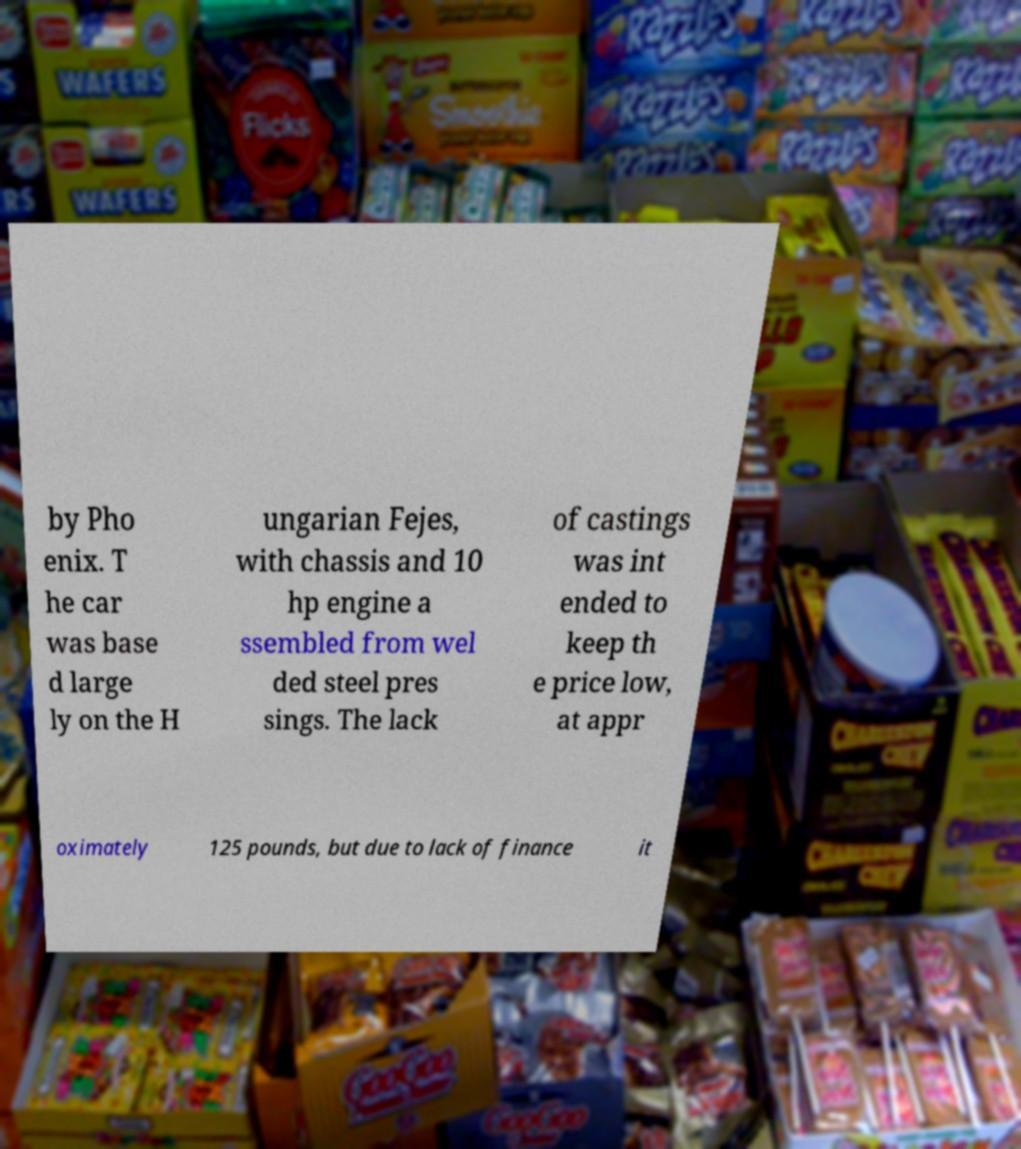For documentation purposes, I need the text within this image transcribed. Could you provide that? by Pho enix. T he car was base d large ly on the H ungarian Fejes, with chassis and 10 hp engine a ssembled from wel ded steel pres sings. The lack of castings was int ended to keep th e price low, at appr oximately 125 pounds, but due to lack of finance it 